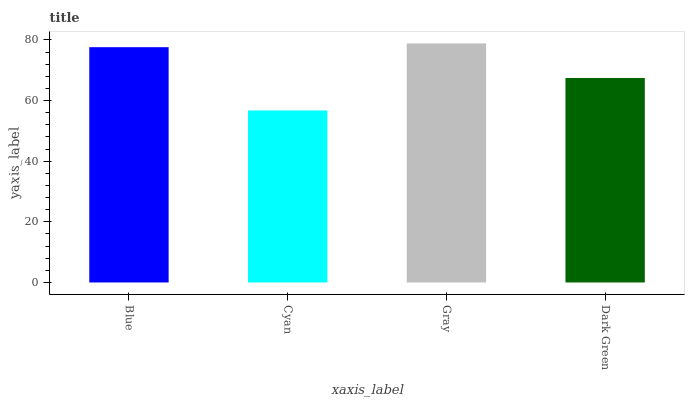Is Gray the minimum?
Answer yes or no. No. Is Cyan the maximum?
Answer yes or no. No. Is Gray greater than Cyan?
Answer yes or no. Yes. Is Cyan less than Gray?
Answer yes or no. Yes. Is Cyan greater than Gray?
Answer yes or no. No. Is Gray less than Cyan?
Answer yes or no. No. Is Blue the high median?
Answer yes or no. Yes. Is Dark Green the low median?
Answer yes or no. Yes. Is Cyan the high median?
Answer yes or no. No. Is Cyan the low median?
Answer yes or no. No. 